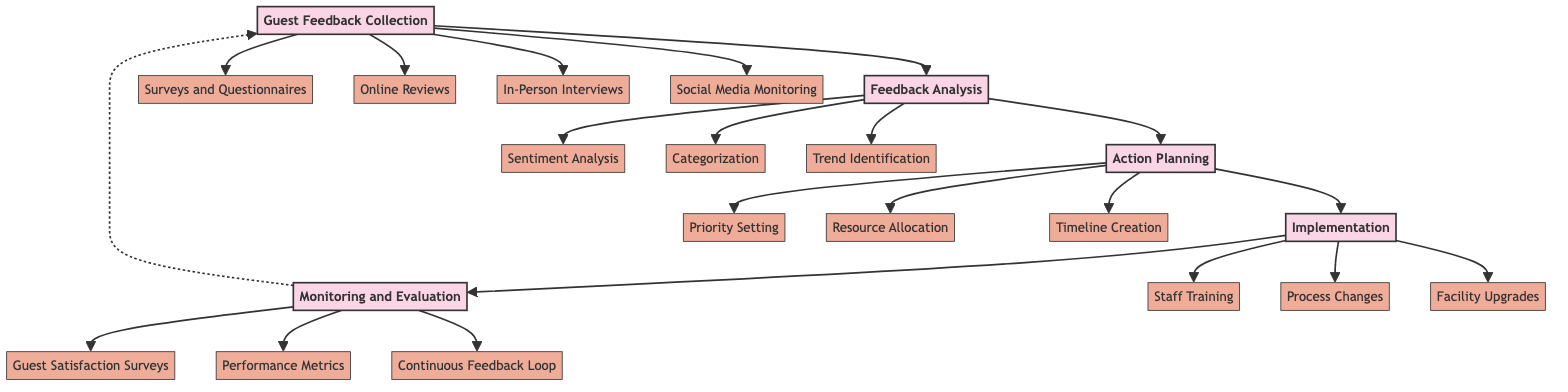What is the first step in the guest feedback handling process? The diagram indicates that the first step is "Guest Feedback Collection," as it is the starting node that all other processes connect to.
Answer: Guest Feedback Collection How many main elements are there in the process? By counting the main nodes in the diagram, we can identify that there are five main elements: Guest Feedback Collection, Feedback Analysis, Action Planning, Implementation, and Monitoring and Evaluation.
Answer: Five Which node follows the Feedback Analysis node? The flow in the diagram directly shows that the node connected to Feedback Analysis is Action Planning, indicating what comes next in the process.
Answer: Action Planning What type of analysis is performed on the feedback collected? The diagram illustrates that "Sentiment Analysis" is one of the analyses performed as part of the Feedback Analysis step, providing insight into guest sentiments.
Answer: Sentiment Analysis Which sub-element focuses on improving physical aspects of the hotel? The sub-element related to physical improvements is "Facility Upgrades," as indicated under the Implementation step in the diagram.
Answer: Facility Upgrades What does the Monitoring and Evaluation step include? According to the diagram, Monitoring and Evaluation includes three sub-elements: "Guest Satisfaction Surveys," "Performance Metrics," and "Continuous Feedback Loop."
Answer: Three elements Which action is prioritized before resource allocation in the Action Planning section? The Action Planning section shows that "Priority Setting" comes before "Resource Allocation," making it the first action to be taken.
Answer: Priority Setting What is the feedback collection method that involves social platforms? The diagram specifies "Social Media Monitoring" as the method used to collect feedback from social platforms.
Answer: Social Media Monitoring How does the process ensure ongoing improvement? The diagram indicates that a "Continuous Feedback Loop" is part of the Monitoring and Evaluation phase, which aids in maintaining a cycle of ongoing improvement.
Answer: Continuous Feedback Loop 